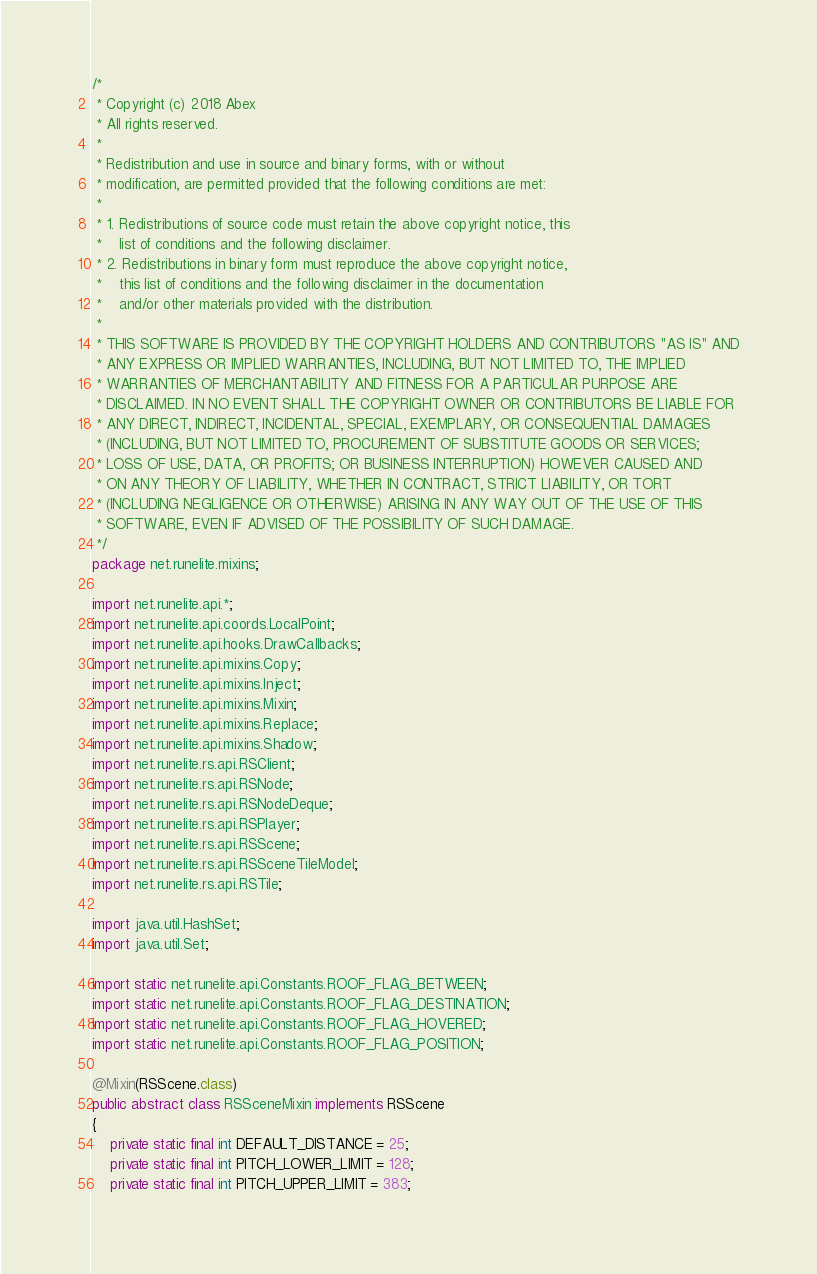Convert code to text. <code><loc_0><loc_0><loc_500><loc_500><_Java_>/*
 * Copyright (c) 2018 Abex
 * All rights reserved.
 *
 * Redistribution and use in source and binary forms, with or without
 * modification, are permitted provided that the following conditions are met:
 *
 * 1. Redistributions of source code must retain the above copyright notice, this
 *    list of conditions and the following disclaimer.
 * 2. Redistributions in binary form must reproduce the above copyright notice,
 *    this list of conditions and the following disclaimer in the documentation
 *    and/or other materials provided with the distribution.
 *
 * THIS SOFTWARE IS PROVIDED BY THE COPYRIGHT HOLDERS AND CONTRIBUTORS "AS IS" AND
 * ANY EXPRESS OR IMPLIED WARRANTIES, INCLUDING, BUT NOT LIMITED TO, THE IMPLIED
 * WARRANTIES OF MERCHANTABILITY AND FITNESS FOR A PARTICULAR PURPOSE ARE
 * DISCLAIMED. IN NO EVENT SHALL THE COPYRIGHT OWNER OR CONTRIBUTORS BE LIABLE FOR
 * ANY DIRECT, INDIRECT, INCIDENTAL, SPECIAL, EXEMPLARY, OR CONSEQUENTIAL DAMAGES
 * (INCLUDING, BUT NOT LIMITED TO, PROCUREMENT OF SUBSTITUTE GOODS OR SERVICES;
 * LOSS OF USE, DATA, OR PROFITS; OR BUSINESS INTERRUPTION) HOWEVER CAUSED AND
 * ON ANY THEORY OF LIABILITY, WHETHER IN CONTRACT, STRICT LIABILITY, OR TORT
 * (INCLUDING NEGLIGENCE OR OTHERWISE) ARISING IN ANY WAY OUT OF THE USE OF THIS
 * SOFTWARE, EVEN IF ADVISED OF THE POSSIBILITY OF SUCH DAMAGE.
 */
package net.runelite.mixins;

import net.runelite.api.*;
import net.runelite.api.coords.LocalPoint;
import net.runelite.api.hooks.DrawCallbacks;
import net.runelite.api.mixins.Copy;
import net.runelite.api.mixins.Inject;
import net.runelite.api.mixins.Mixin;
import net.runelite.api.mixins.Replace;
import net.runelite.api.mixins.Shadow;
import net.runelite.rs.api.RSClient;
import net.runelite.rs.api.RSNode;
import net.runelite.rs.api.RSNodeDeque;
import net.runelite.rs.api.RSPlayer;
import net.runelite.rs.api.RSScene;
import net.runelite.rs.api.RSSceneTileModel;
import net.runelite.rs.api.RSTile;

import java.util.HashSet;
import java.util.Set;

import static net.runelite.api.Constants.ROOF_FLAG_BETWEEN;
import static net.runelite.api.Constants.ROOF_FLAG_DESTINATION;
import static net.runelite.api.Constants.ROOF_FLAG_HOVERED;
import static net.runelite.api.Constants.ROOF_FLAG_POSITION;

@Mixin(RSScene.class)
public abstract class RSSceneMixin implements RSScene
{
	private static final int DEFAULT_DISTANCE = 25;
	private static final int PITCH_LOWER_LIMIT = 128;
	private static final int PITCH_UPPER_LIMIT = 383;
</code> 